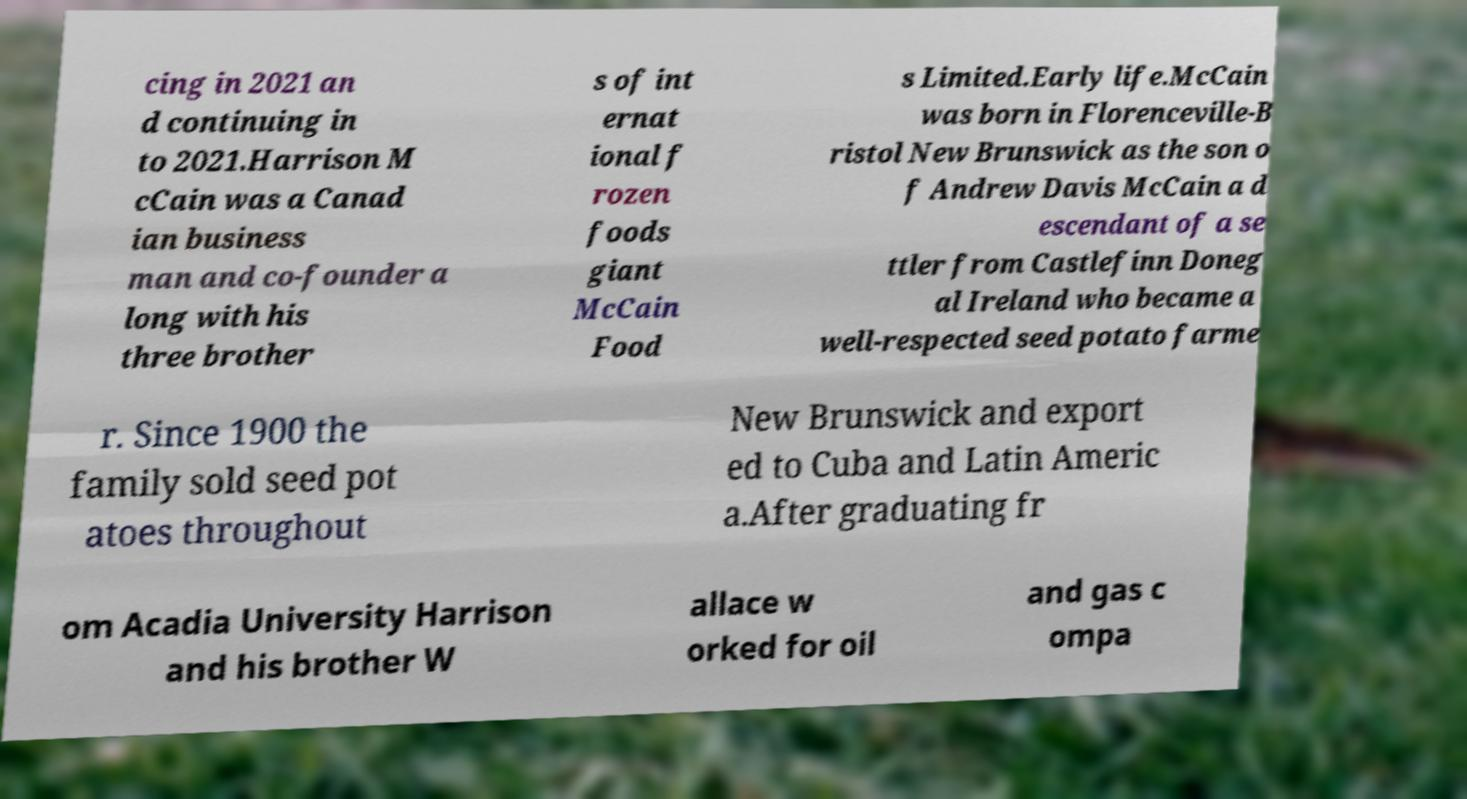Please identify and transcribe the text found in this image. cing in 2021 an d continuing in to 2021.Harrison M cCain was a Canad ian business man and co-founder a long with his three brother s of int ernat ional f rozen foods giant McCain Food s Limited.Early life.McCain was born in Florenceville-B ristol New Brunswick as the son o f Andrew Davis McCain a d escendant of a se ttler from Castlefinn Doneg al Ireland who became a well-respected seed potato farme r. Since 1900 the family sold seed pot atoes throughout New Brunswick and export ed to Cuba and Latin Americ a.After graduating fr om Acadia University Harrison and his brother W allace w orked for oil and gas c ompa 